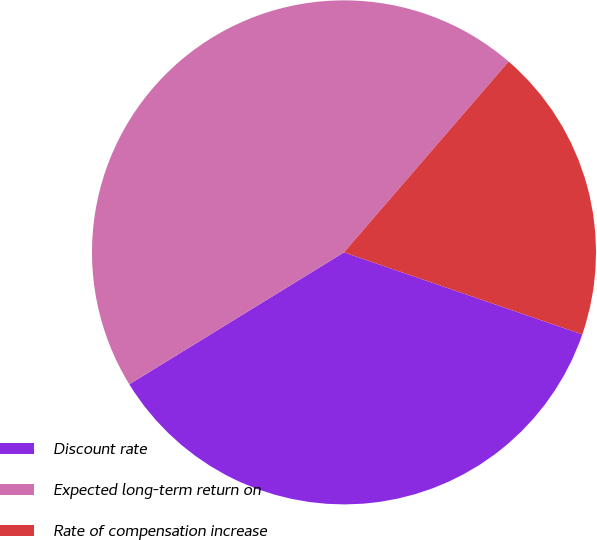Convert chart. <chart><loc_0><loc_0><loc_500><loc_500><pie_chart><fcel>Discount rate<fcel>Expected long-term return on<fcel>Rate of compensation increase<nl><fcel>35.95%<fcel>45.1%<fcel>18.95%<nl></chart> 